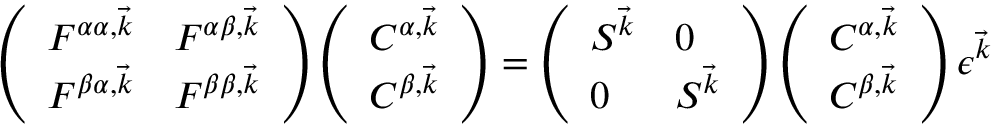Convert formula to latex. <formula><loc_0><loc_0><loc_500><loc_500>\begin{array} { r } { \left ( \begin{array} { l l } { F ^ { \alpha \alpha , \vec { k } } } & { F ^ { \alpha \beta , \vec { k } } } \\ { F ^ { \beta \alpha , \vec { k } } } & { F ^ { \beta \beta , \vec { k } } } \end{array} \right ) \left ( \begin{array} { l } { C ^ { \alpha , \vec { k } } } \\ { C ^ { \beta , \vec { k } } } \end{array} \right ) = \left ( \begin{array} { l l } { S ^ { \vec { k } } } & { 0 } \\ { 0 } & { S ^ { \vec { k } } } \end{array} \right ) \left ( \begin{array} { l } { C ^ { \alpha , \vec { k } } } \\ { C ^ { \beta , \vec { k } } } \end{array} \right ) \epsilon ^ { \vec { k } } \quad } \end{array}</formula> 